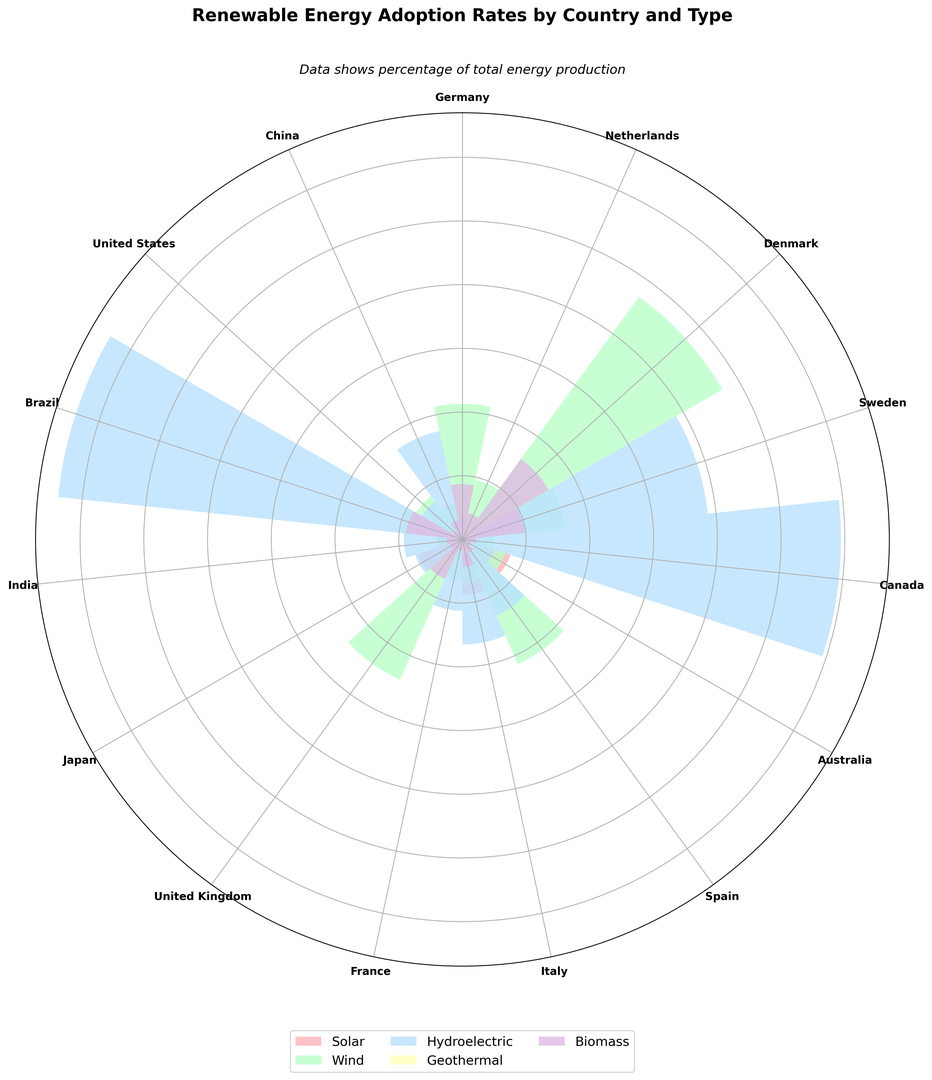What's the country with the highest adoption rate of wind energy? To determine the country with the highest adoption rate of wind energy, look at the bars in the rose chart associated with the wind energy type (likely color-coded consistently). The country with the longest bar in this category is Denmark.
Answer: Denmark Which country has a higher adoption rate of solar energy, Australia or France? Compare the lengths of the bars for solar energy between Australia and France. Australia's bar is clearly longer than France's in the solar energy category.
Answer: Australia Which two countries combined have the highest biometric energy adoption rate, and what is it? Identify the two longest bars in the biomass category: Sweden (9.8%) and Denmark (15.6%). Add these values together: 9.8 + 15.6 = 25.4%.
Answer: Sweden and Denmark, 25.4% Among Germany, Japan, and Spain, which country has the least adoption rate of hydroelectric energy? Compare the bars representing hydroelectric energy for Germany, Japan, and Spain. Germany has 3.2%, Japan has 7.8%, and Spain has 13.1%. Thus, Germany has the lowest rate.
Answer: Germany For geothermal energy, what is the average adoption rate across all countries? Identify the bars for geothermal energy, then sum their values and divide by the number of countries (15). The rates are: 0.1, 0.2, 0.4, 0, 0, 0.3, 0, 0, 2.1, 0, 0, 0, 0, 0, 0. Total is 3.1%, divided by 15 is 0.207%.
Answer: 0.207% What is the difference in adoption rates of hydroelectric energy between Brazil and Canada? Look at Brazil and Canada's bars for hydroelectric. Brazil's is 63.8% and Canada's is 59.4%. The difference is 63.8 - 59.4 = 4.4%.
Answer: 4.4% In general, which renewable energy type has the lowest adoption rates across all countries? Observe the length of the bars for each energy type across all countries and identify which set of bars are consistently shorter. Geothermal energy has the smallest bars overall, indicating the lowest adoption rates.
Answer: Geothermal Compare the adoption rates of wind energy in Germany and the United Kingdom. What can you conclude? Compare the bars for wind energy in Germany (21.3%) and the United Kingdom (24.1%). The UK's bar is slightly longer, indicating it has a higher adoption rate of wind energy than Germany.
Answer: The United Kingdom has a higher adoption rate Which country has the highest adoption rate of hydroelectric energy, and how does it visually compare to other countries' adoption rates of hydroelectric energy? Identify the longest bar in the hydroelectric energy category, which belongs to Brazil (63.8%). This bar is significantly longer compared to others, indicating a much higher adoption rate.
Answer: Brazil, much higher than others What is the sum of the adoption rates for solar and biomass energy in Italy? Identify Italy's bars for solar (8.7%) and biomass (4.3%), then sum these values: 8.7 + 4.3 = 13%.
Answer: 13% 